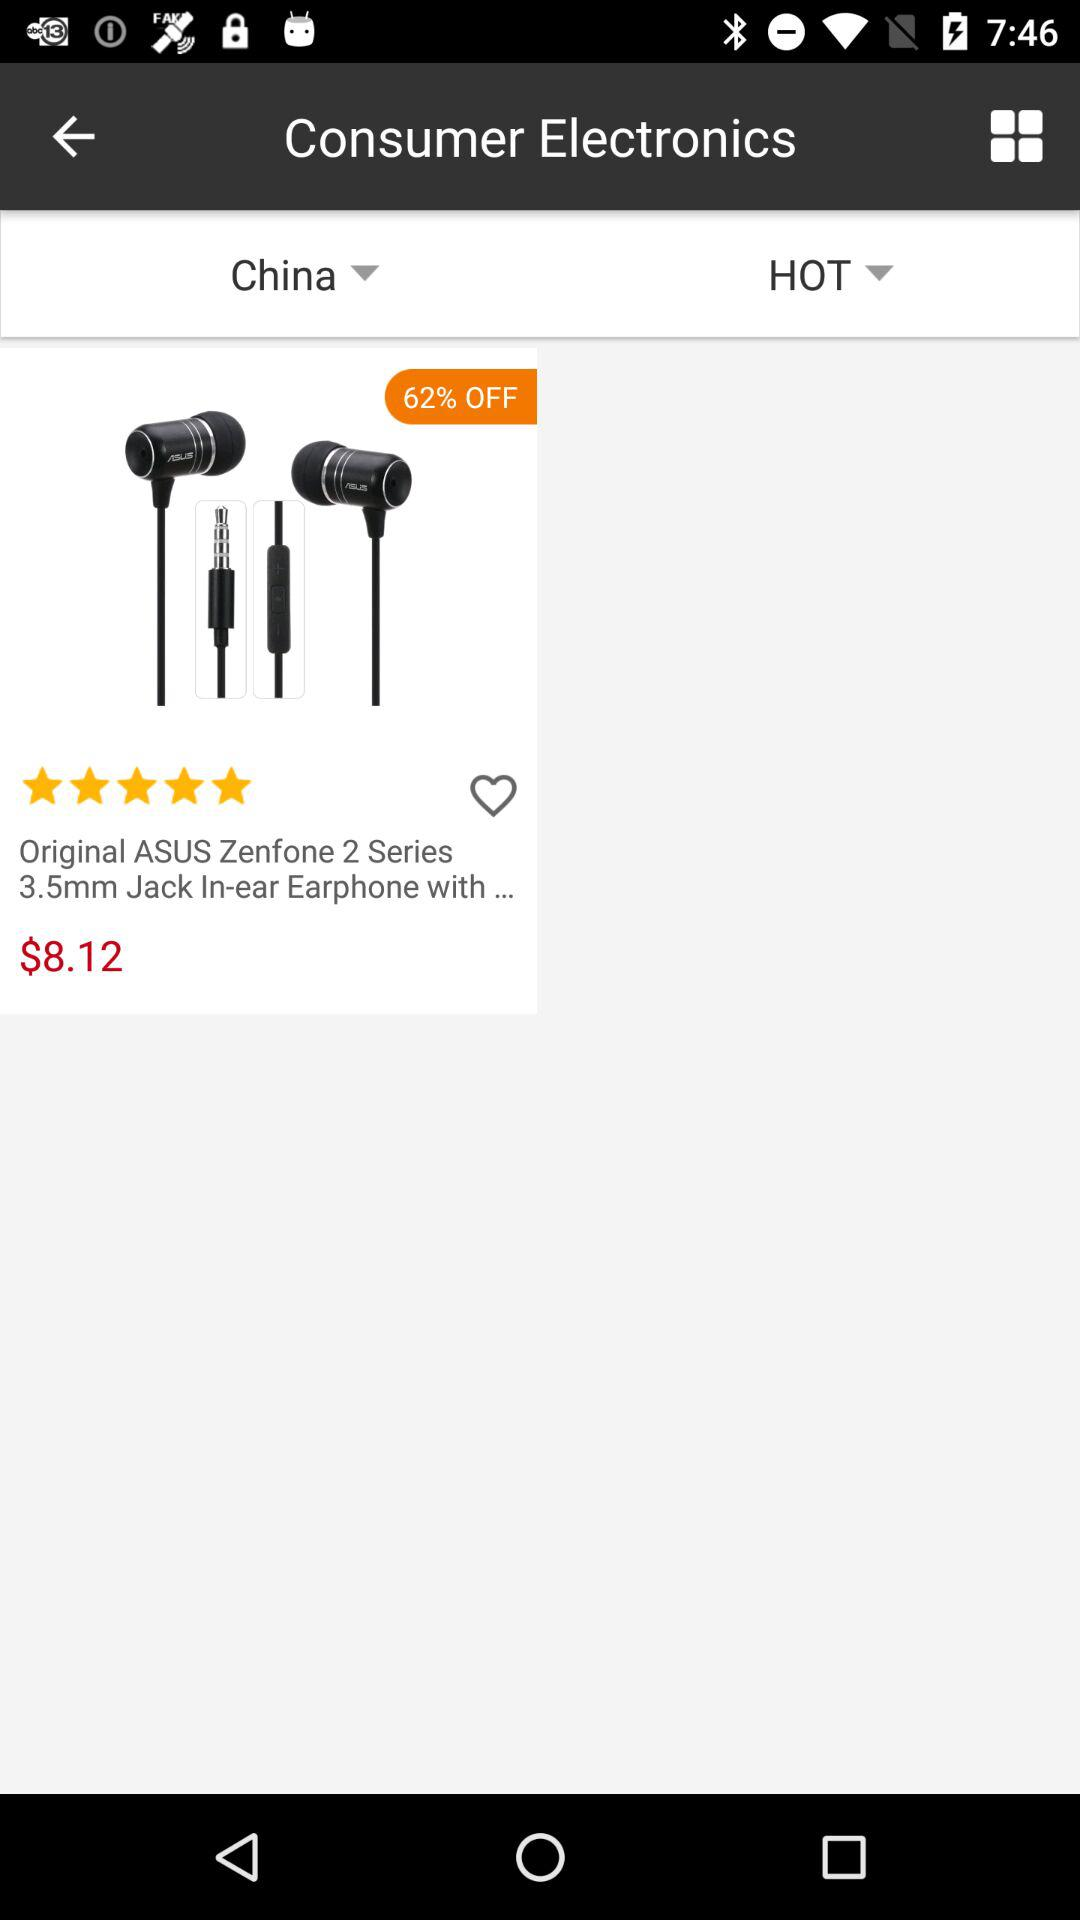Which countries are available in the drop-down menu?
When the provided information is insufficient, respond with <no answer>. <no answer> 